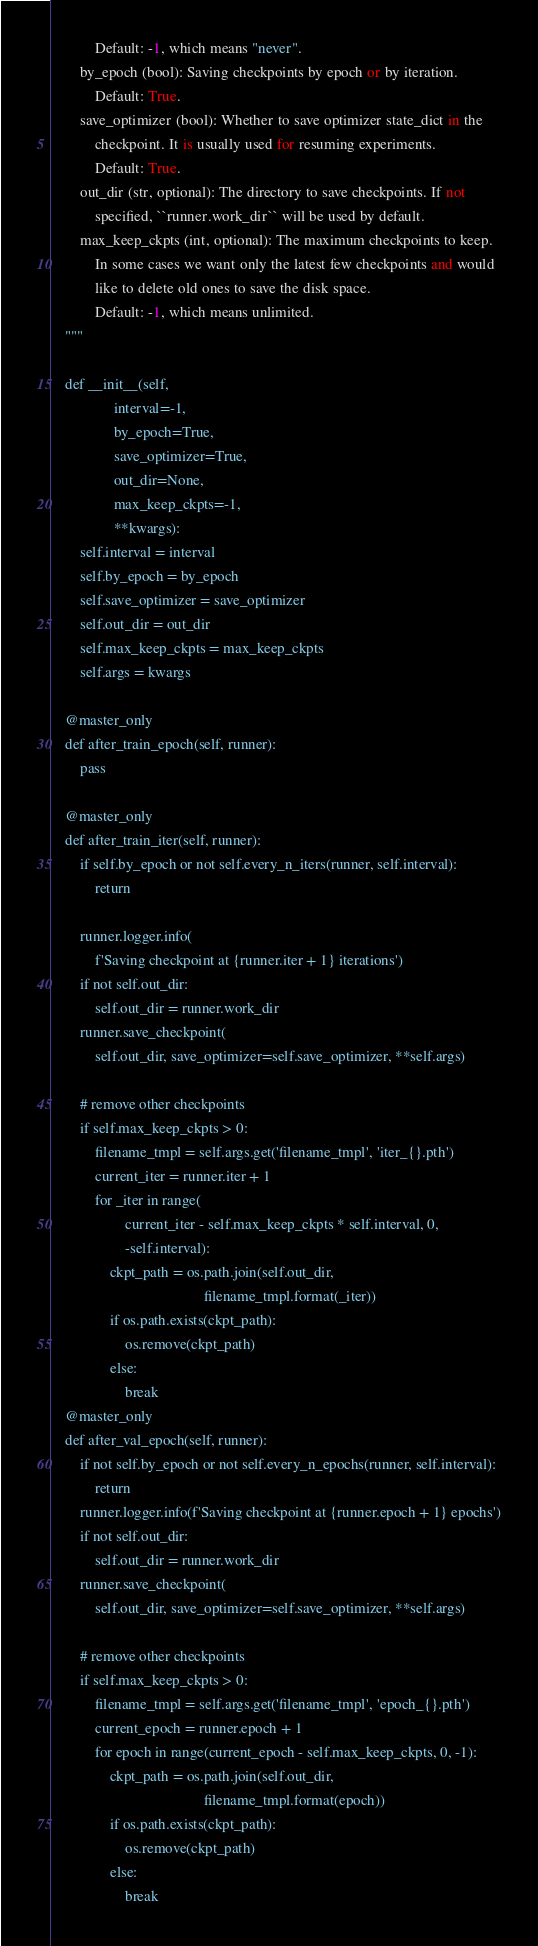Convert code to text. <code><loc_0><loc_0><loc_500><loc_500><_Python_>            Default: -1, which means "never".
        by_epoch (bool): Saving checkpoints by epoch or by iteration.
            Default: True.
        save_optimizer (bool): Whether to save optimizer state_dict in the
            checkpoint. It is usually used for resuming experiments.
            Default: True.
        out_dir (str, optional): The directory to save checkpoints. If not
            specified, ``runner.work_dir`` will be used by default.
        max_keep_ckpts (int, optional): The maximum checkpoints to keep.
            In some cases we want only the latest few checkpoints and would
            like to delete old ones to save the disk space.
            Default: -1, which means unlimited.
    """

    def __init__(self,
                 interval=-1,
                 by_epoch=True,
                 save_optimizer=True,
                 out_dir=None,
                 max_keep_ckpts=-1,
                 **kwargs):
        self.interval = interval
        self.by_epoch = by_epoch
        self.save_optimizer = save_optimizer
        self.out_dir = out_dir
        self.max_keep_ckpts = max_keep_ckpts
        self.args = kwargs

    @master_only
    def after_train_epoch(self, runner):
        pass

    @master_only
    def after_train_iter(self, runner):
        if self.by_epoch or not self.every_n_iters(runner, self.interval):
            return

        runner.logger.info(
            f'Saving checkpoint at {runner.iter + 1} iterations')
        if not self.out_dir:
            self.out_dir = runner.work_dir
        runner.save_checkpoint(
            self.out_dir, save_optimizer=self.save_optimizer, **self.args)

        # remove other checkpoints
        if self.max_keep_ckpts > 0:
            filename_tmpl = self.args.get('filename_tmpl', 'iter_{}.pth')
            current_iter = runner.iter + 1
            for _iter in range(
                    current_iter - self.max_keep_ckpts * self.interval, 0,
                    -self.interval):
                ckpt_path = os.path.join(self.out_dir,
                                         filename_tmpl.format(_iter))
                if os.path.exists(ckpt_path):
                    os.remove(ckpt_path)
                else:
                    break
    @master_only
    def after_val_epoch(self, runner):
        if not self.by_epoch or not self.every_n_epochs(runner, self.interval):
            return
        runner.logger.info(f'Saving checkpoint at {runner.epoch + 1} epochs')
        if not self.out_dir:
            self.out_dir = runner.work_dir
        runner.save_checkpoint(
            self.out_dir, save_optimizer=self.save_optimizer, **self.args)

        # remove other checkpoints
        if self.max_keep_ckpts > 0:
            filename_tmpl = self.args.get('filename_tmpl', 'epoch_{}.pth')
            current_epoch = runner.epoch + 1
            for epoch in range(current_epoch - self.max_keep_ckpts, 0, -1):
                ckpt_path = os.path.join(self.out_dir,
                                         filename_tmpl.format(epoch))
                if os.path.exists(ckpt_path):
                    os.remove(ckpt_path)
                else:
                    break</code> 